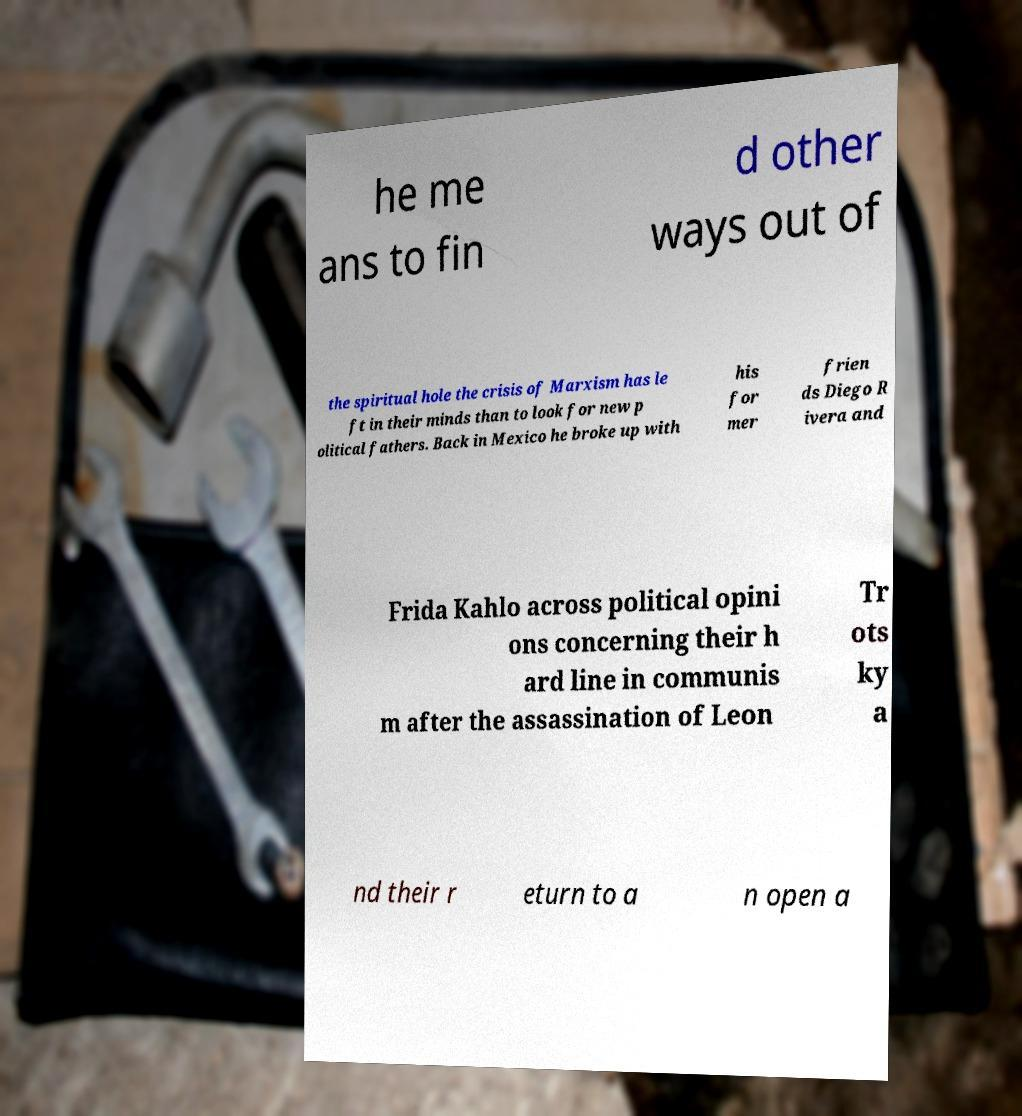What messages or text are displayed in this image? I need them in a readable, typed format. he me ans to fin d other ways out of the spiritual hole the crisis of Marxism has le ft in their minds than to look for new p olitical fathers. Back in Mexico he broke up with his for mer frien ds Diego R ivera and Frida Kahlo across political opini ons concerning their h ard line in communis m after the assassination of Leon Tr ots ky a nd their r eturn to a n open a 